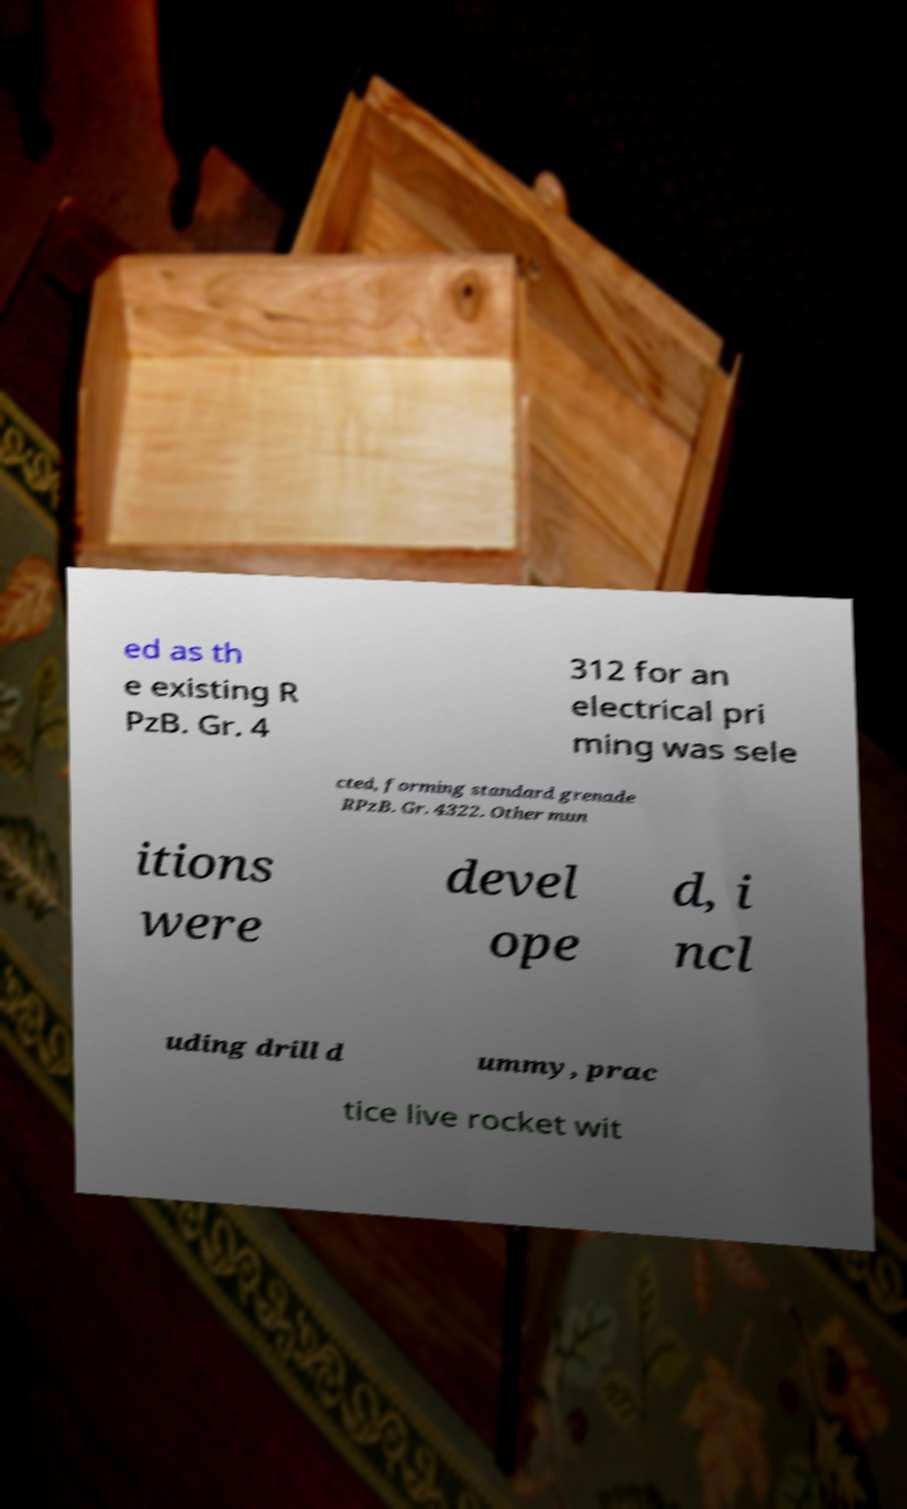Could you assist in decoding the text presented in this image and type it out clearly? ed as th e existing R PzB. Gr. 4 312 for an electrical pri ming was sele cted, forming standard grenade RPzB. Gr. 4322. Other mun itions were devel ope d, i ncl uding drill d ummy, prac tice live rocket wit 